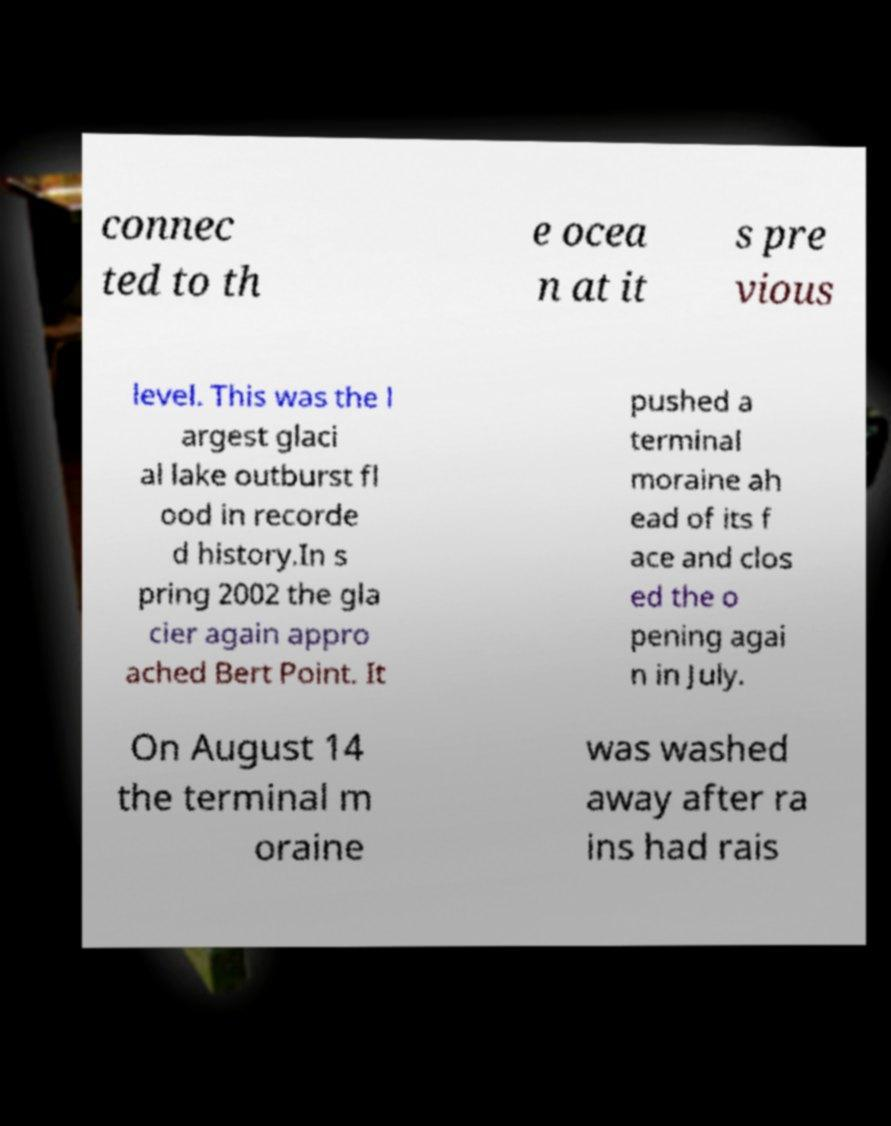For documentation purposes, I need the text within this image transcribed. Could you provide that? connec ted to th e ocea n at it s pre vious level. This was the l argest glaci al lake outburst fl ood in recorde d history.In s pring 2002 the gla cier again appro ached Bert Point. It pushed a terminal moraine ah ead of its f ace and clos ed the o pening agai n in July. On August 14 the terminal m oraine was washed away after ra ins had rais 